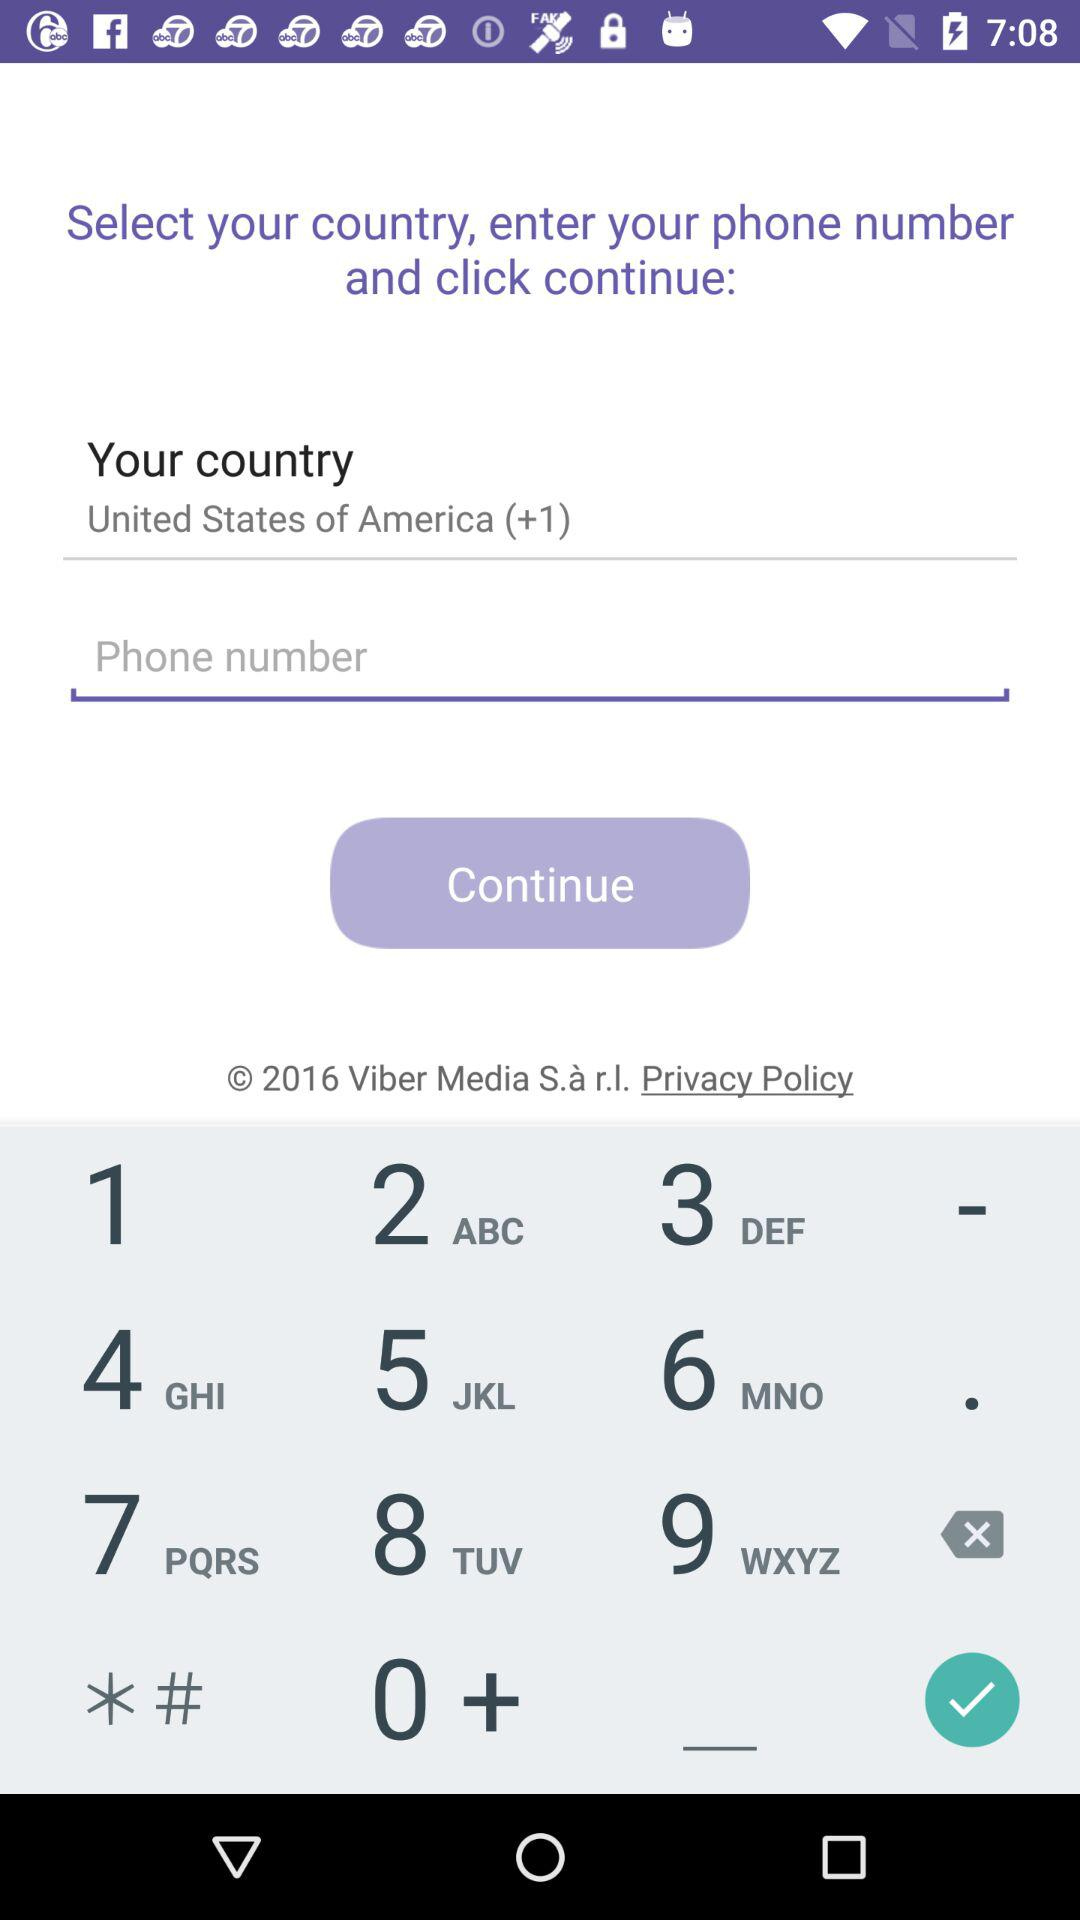What's the country's name and country code? The country's name is "United States of America" and the country code is +1. 